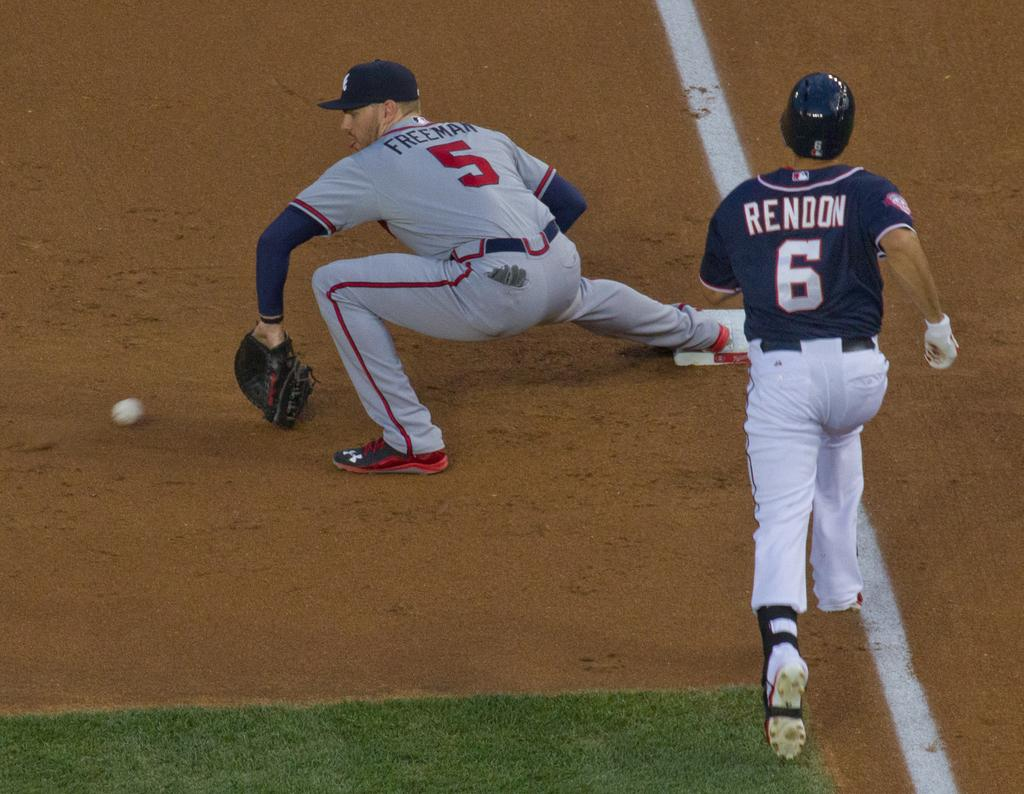<image>
Present a compact description of the photo's key features. two baseball players number 5 and 6 on a field 